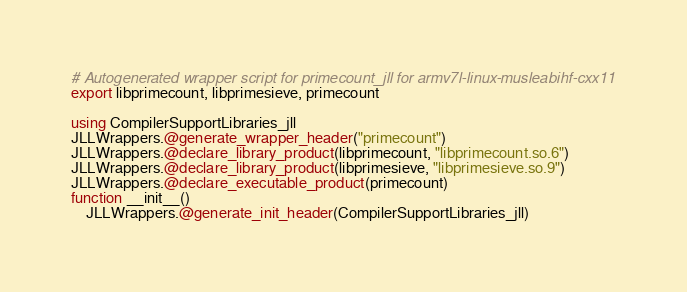<code> <loc_0><loc_0><loc_500><loc_500><_Julia_># Autogenerated wrapper script for primecount_jll for armv7l-linux-musleabihf-cxx11
export libprimecount, libprimesieve, primecount

using CompilerSupportLibraries_jll
JLLWrappers.@generate_wrapper_header("primecount")
JLLWrappers.@declare_library_product(libprimecount, "libprimecount.so.6")
JLLWrappers.@declare_library_product(libprimesieve, "libprimesieve.so.9")
JLLWrappers.@declare_executable_product(primecount)
function __init__()
    JLLWrappers.@generate_init_header(CompilerSupportLibraries_jll)</code> 